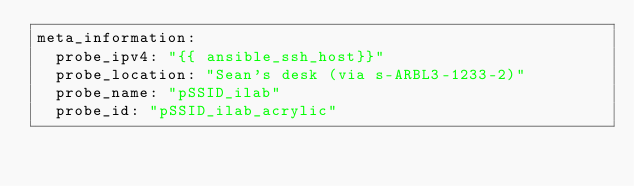Convert code to text. <code><loc_0><loc_0><loc_500><loc_500><_YAML_>meta_information:
  probe_ipv4: "{{ ansible_ssh_host}}"
  probe_location: "Sean's desk (via s-ARBL3-1233-2)"
  probe_name: "pSSID_ilab"
  probe_id: "pSSID_ilab_acrylic"
</code> 